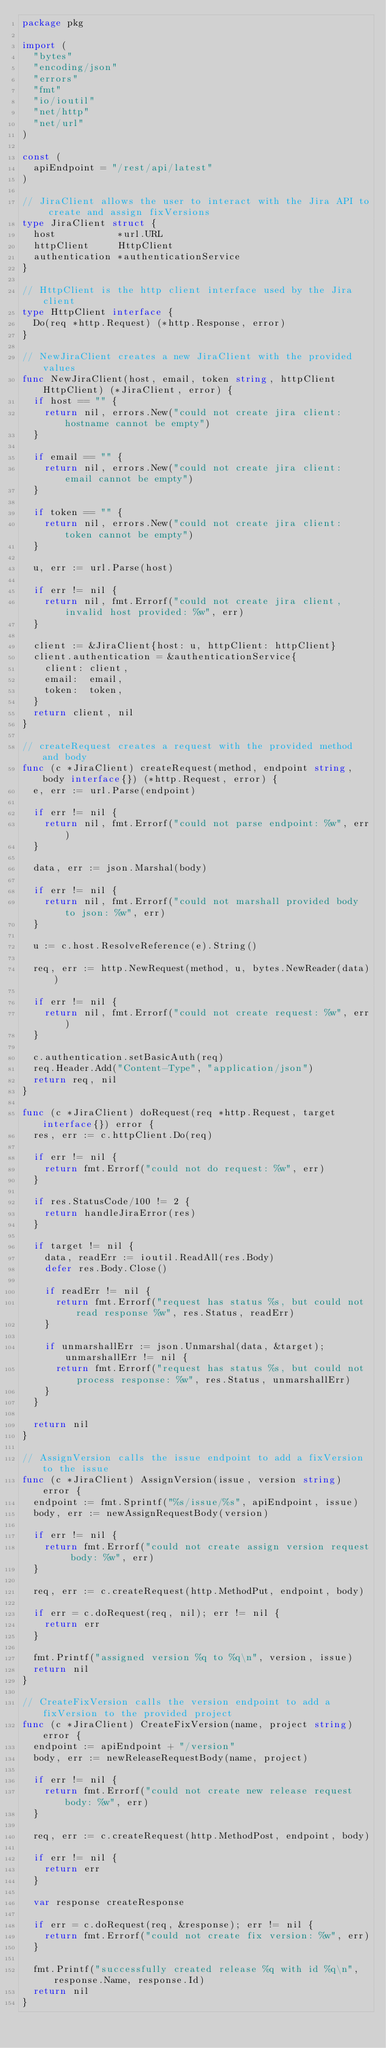<code> <loc_0><loc_0><loc_500><loc_500><_Go_>package pkg

import (
	"bytes"
	"encoding/json"
	"errors"
	"fmt"
	"io/ioutil"
	"net/http"
	"net/url"
)

const (
	apiEndpoint = "/rest/api/latest"
)

// JiraClient allows the user to interact with the Jira API to create and assign fixVersions
type JiraClient struct {
	host           *url.URL
	httpClient     HttpClient
	authentication *authenticationService
}

// HttpClient is the http client interface used by the Jira client
type HttpClient interface {
	Do(req *http.Request) (*http.Response, error)
}

// NewJiraClient creates a new JiraClient with the provided values
func NewJiraClient(host, email, token string, httpClient HttpClient) (*JiraClient, error) {
	if host == "" {
		return nil, errors.New("could not create jira client: hostname cannot be empty")
	}

	if email == "" {
		return nil, errors.New("could not create jira client: email cannot be empty")
	}

	if token == "" {
		return nil, errors.New("could not create jira client: token cannot be empty")
	}

	u, err := url.Parse(host)

	if err != nil {
		return nil, fmt.Errorf("could not create jira client, invalid host provided: %w", err)
	}

	client := &JiraClient{host: u, httpClient: httpClient}
	client.authentication = &authenticationService{
		client: client,
		email:  email,
		token:  token,
	}
	return client, nil
}

// createRequest creates a request with the provided method and body
func (c *JiraClient) createRequest(method, endpoint string, body interface{}) (*http.Request, error) {
	e, err := url.Parse(endpoint)

	if err != nil {
		return nil, fmt.Errorf("could not parse endpoint: %w", err)
	}

	data, err := json.Marshal(body)

	if err != nil {
		return nil, fmt.Errorf("could not marshall provided body to json: %w", err)
	}

	u := c.host.ResolveReference(e).String()

	req, err := http.NewRequest(method, u, bytes.NewReader(data))

	if err != nil {
		return nil, fmt.Errorf("could not create request: %w", err)
	}

	c.authentication.setBasicAuth(req)
	req.Header.Add("Content-Type", "application/json")
	return req, nil
}

func (c *JiraClient) doRequest(req *http.Request, target interface{}) error {
	res, err := c.httpClient.Do(req)

	if err != nil {
		return fmt.Errorf("could not do request: %w", err)
	}

	if res.StatusCode/100 != 2 {
		return handleJiraError(res)
	}

	if target != nil {
		data, readErr := ioutil.ReadAll(res.Body)
		defer res.Body.Close()

		if readErr != nil {
			return fmt.Errorf("request has status %s, but could not read response %w", res.Status, readErr)
		}

		if unmarshallErr := json.Unmarshal(data, &target); unmarshallErr != nil {
			return fmt.Errorf("request has status %s, but could not process response: %w", res.Status, unmarshallErr)
		}
	}

	return nil
}

// AssignVersion calls the issue endpoint to add a fixVersion to the issue
func (c *JiraClient) AssignVersion(issue, version string) error {
	endpoint := fmt.Sprintf("%s/issue/%s", apiEndpoint, issue)
	body, err := newAssignRequestBody(version)

	if err != nil {
		return fmt.Errorf("could not create assign version request body: %w", err)
	}

	req, err := c.createRequest(http.MethodPut, endpoint, body)

	if err = c.doRequest(req, nil); err != nil {
		return err
	}

	fmt.Printf("assigned version %q to %q\n", version, issue)
	return nil
}

// CreateFixVersion calls the version endpoint to add a fixVersion to the provided project
func (c *JiraClient) CreateFixVersion(name, project string) error {
	endpoint := apiEndpoint + "/version"
	body, err := newReleaseRequestBody(name, project)

	if err != nil {
		return fmt.Errorf("could not create new release request body: %w", err)
	}

	req, err := c.createRequest(http.MethodPost, endpoint, body)

	if err != nil {
		return err
	}

	var response createResponse

	if err = c.doRequest(req, &response); err != nil {
		return fmt.Errorf("could not create fix version: %w", err)
	}

	fmt.Printf("successfully created release %q with id %q\n", response.Name, response.Id)
	return nil
}
</code> 